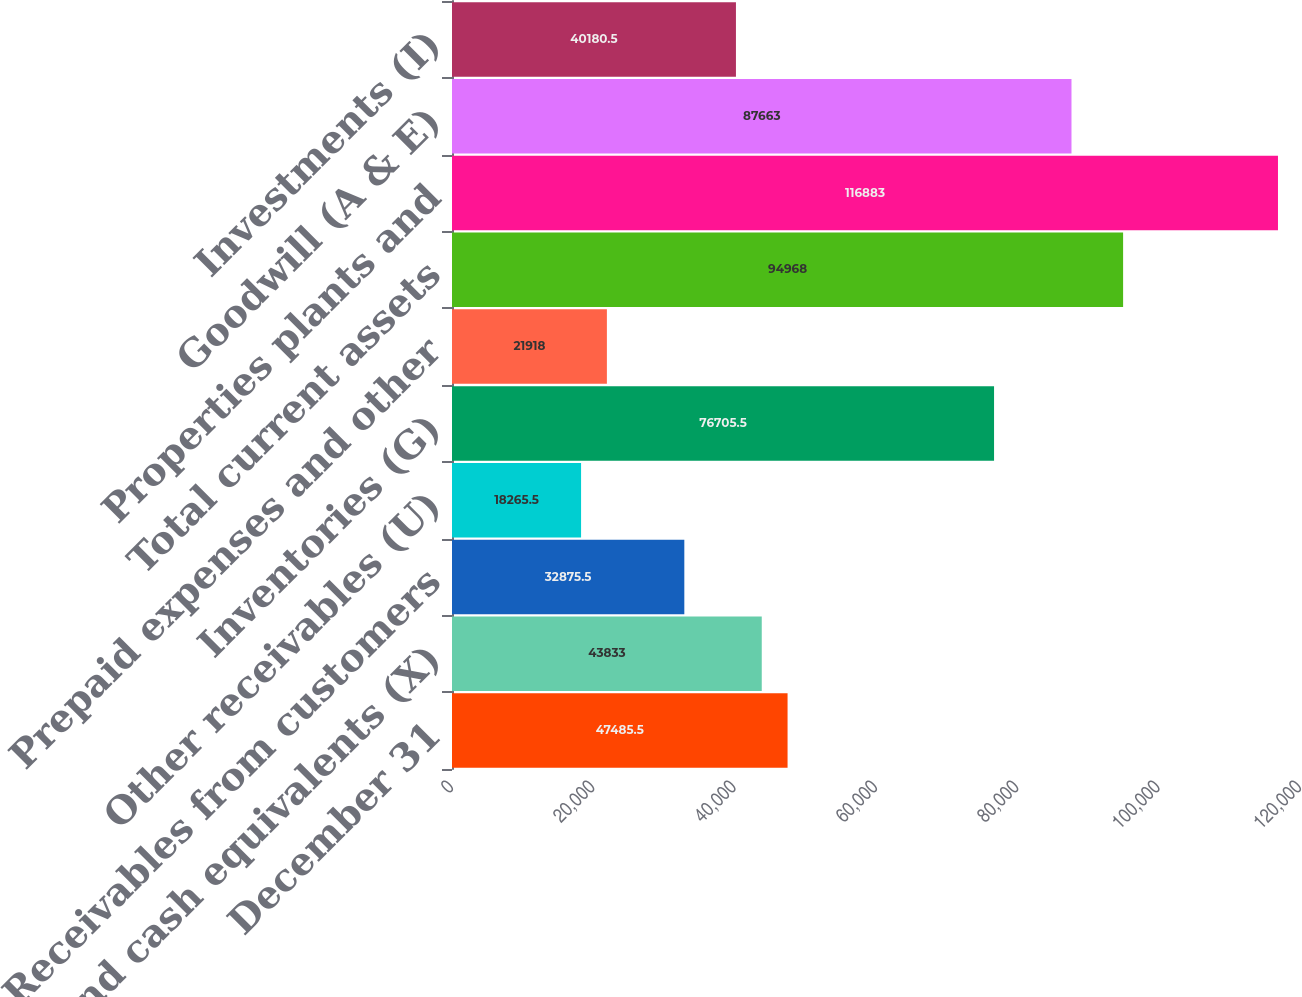Convert chart to OTSL. <chart><loc_0><loc_0><loc_500><loc_500><bar_chart><fcel>December 31<fcel>Cash and cash equivalents (X)<fcel>Receivables from customers<fcel>Other receivables (U)<fcel>Inventories (G)<fcel>Prepaid expenses and other<fcel>Total current assets<fcel>Properties plants and<fcel>Goodwill (A & E)<fcel>Investments (I)<nl><fcel>47485.5<fcel>43833<fcel>32875.5<fcel>18265.5<fcel>76705.5<fcel>21918<fcel>94968<fcel>116883<fcel>87663<fcel>40180.5<nl></chart> 